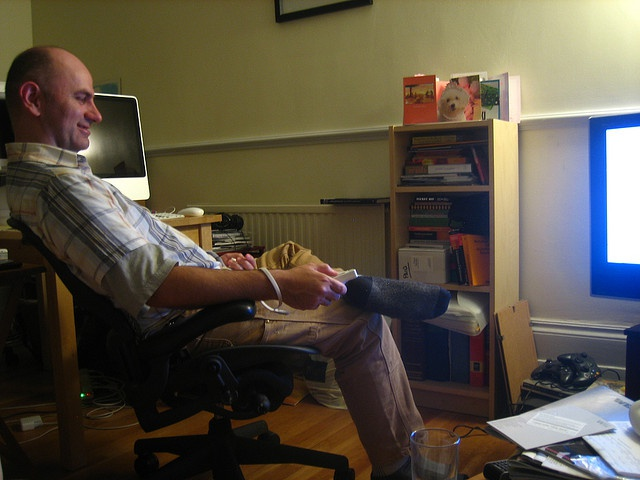Describe the objects in this image and their specific colors. I can see people in olive, black, maroon, and gray tones, chair in olive, black, maroon, and navy tones, tv in olive, white, blue, and darkblue tones, tv in olive, black, beige, darkgreen, and gray tones, and book in olive, lightgray, and darkgray tones in this image. 